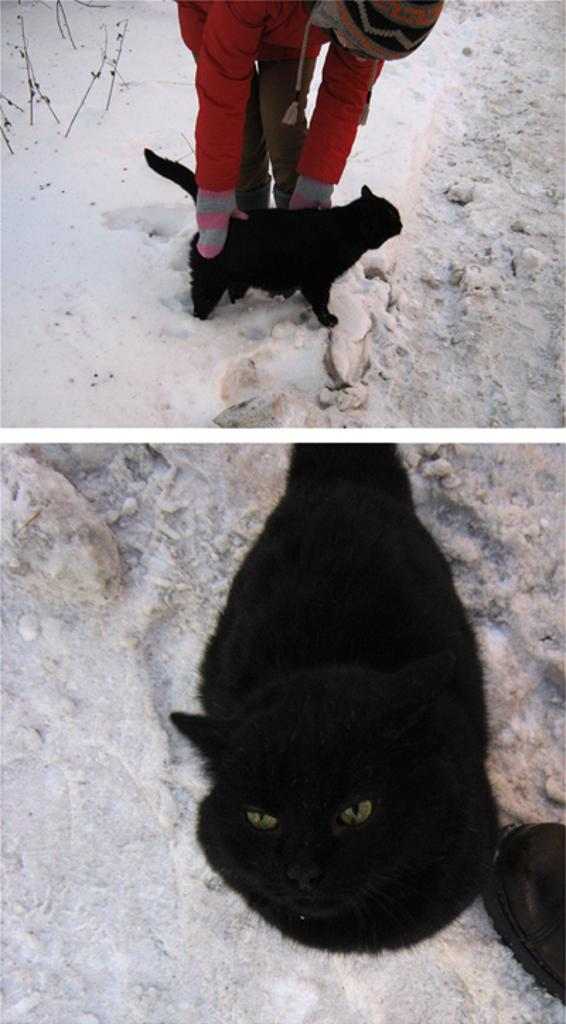What is the person in the image holding? The person is holding a cat in the image. Is there more than one image of the cat in the picture? Yes, there is a separate image of the cat lying down. What type of plot is the cat involved in within the image? There is no plot depicted in the image; it simply shows a person holding a cat and a separate image of the cat lying down. 